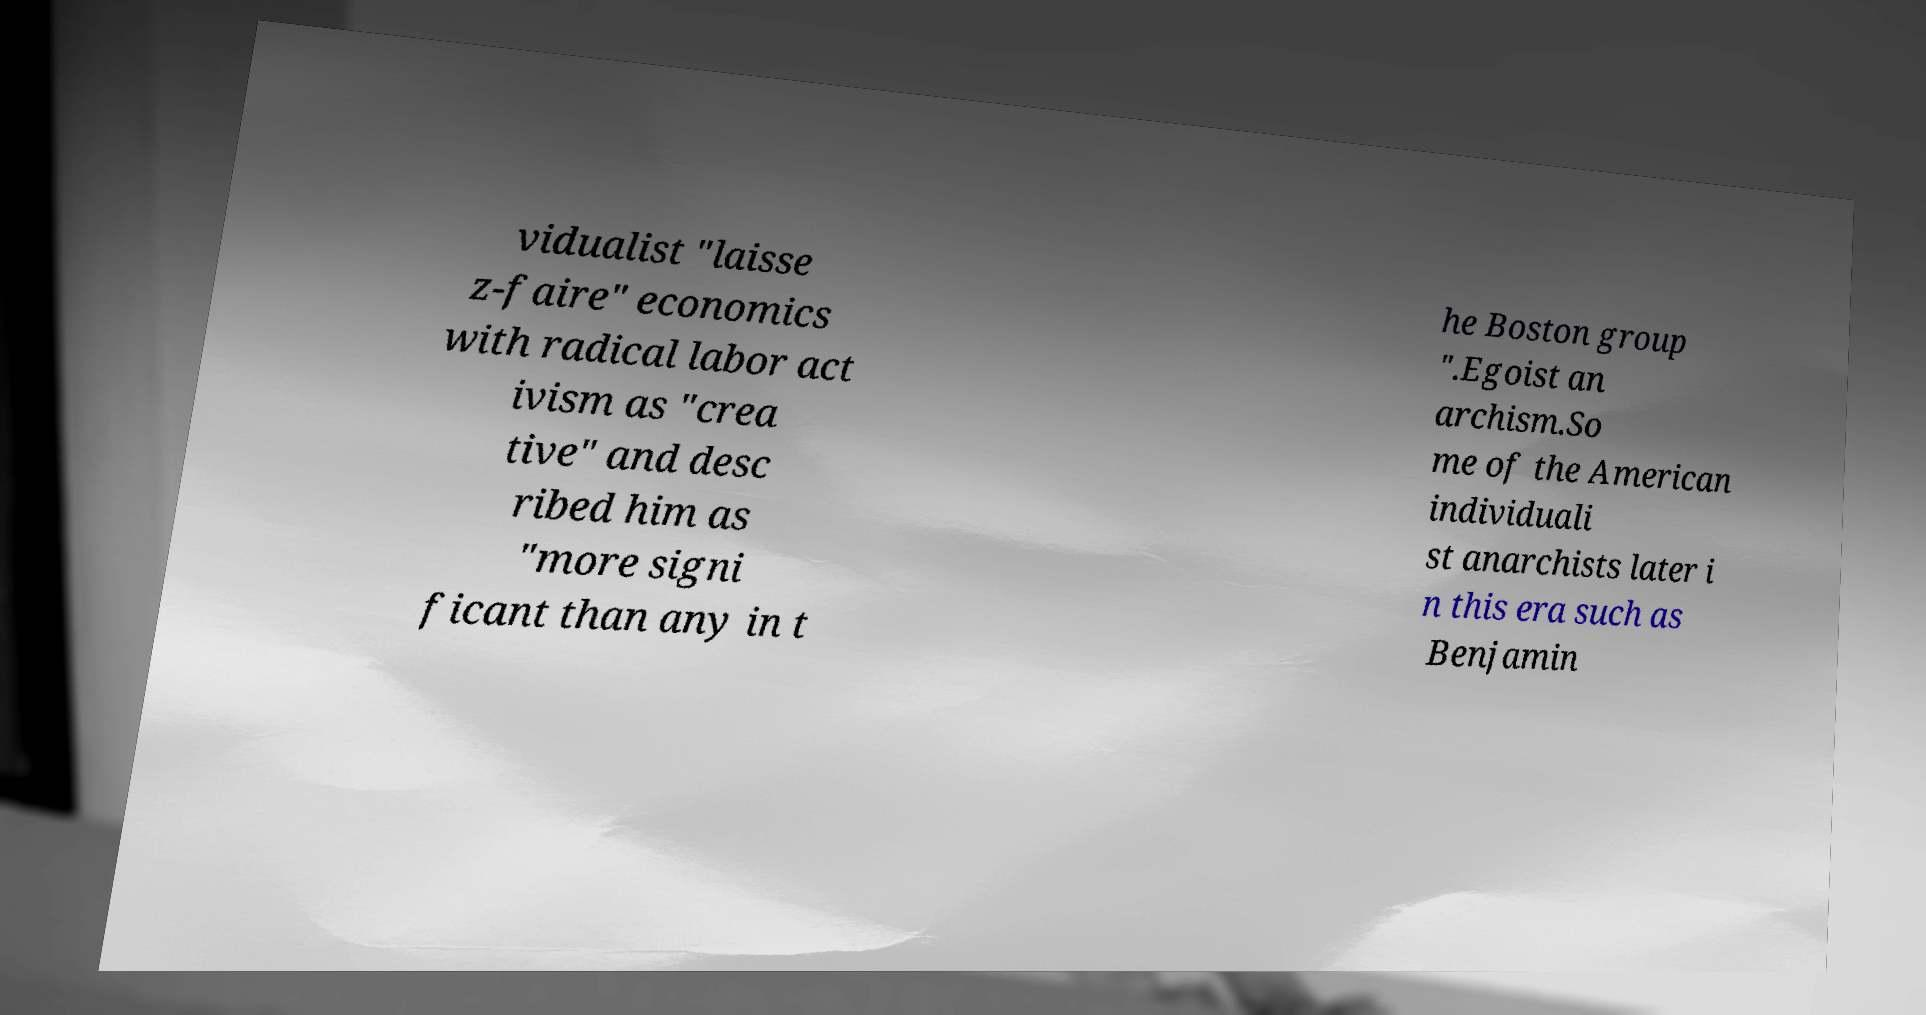Can you accurately transcribe the text from the provided image for me? vidualist "laisse z-faire" economics with radical labor act ivism as "crea tive" and desc ribed him as "more signi ficant than any in t he Boston group ".Egoist an archism.So me of the American individuali st anarchists later i n this era such as Benjamin 